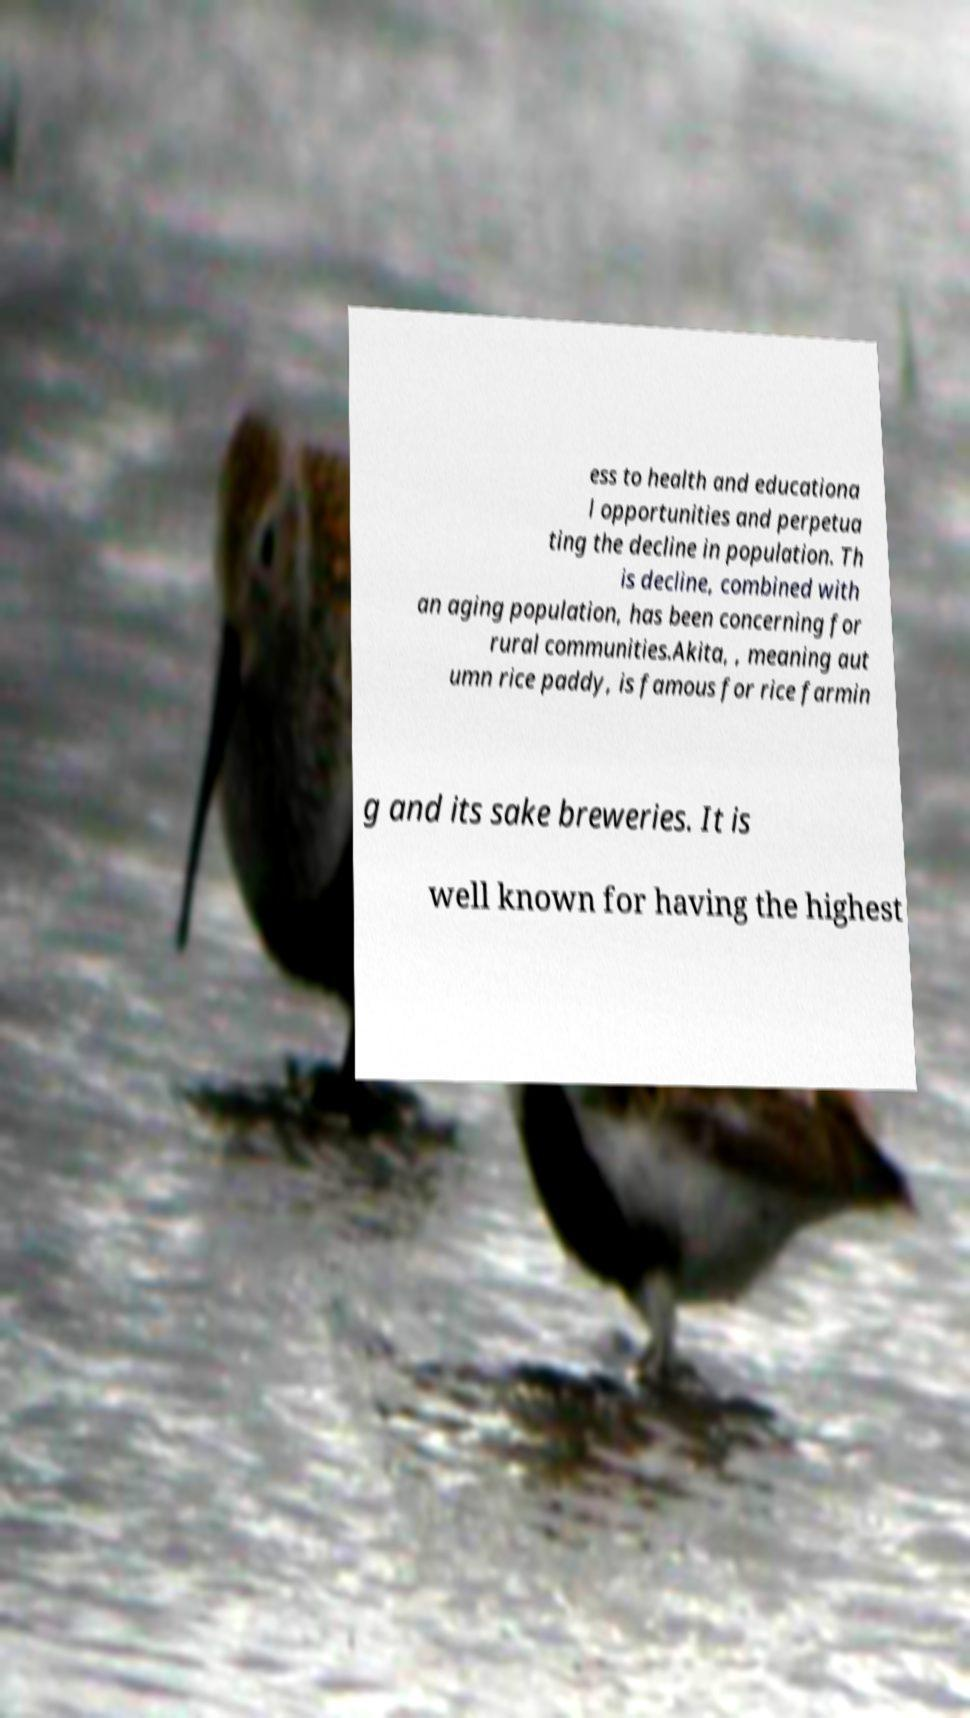Can you read and provide the text displayed in the image?This photo seems to have some interesting text. Can you extract and type it out for me? ess to health and educationa l opportunities and perpetua ting the decline in population. Th is decline, combined with an aging population, has been concerning for rural communities.Akita, , meaning aut umn rice paddy, is famous for rice farmin g and its sake breweries. It is well known for having the highest 